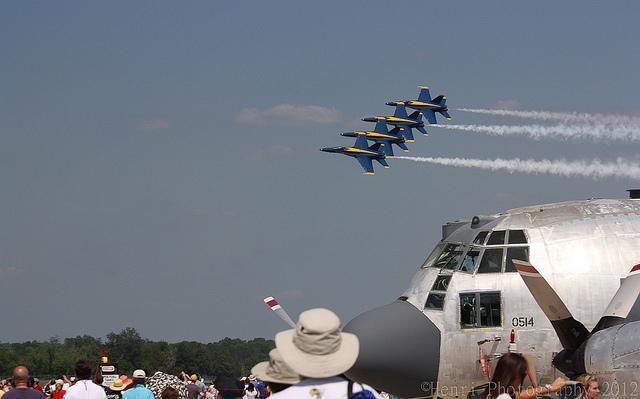How many trails of smoke are there?
Give a very brief answer. 3. How many people can be seen?
Give a very brief answer. 1. How many windows on this airplane are touched by red or orange paint?
Give a very brief answer. 0. 